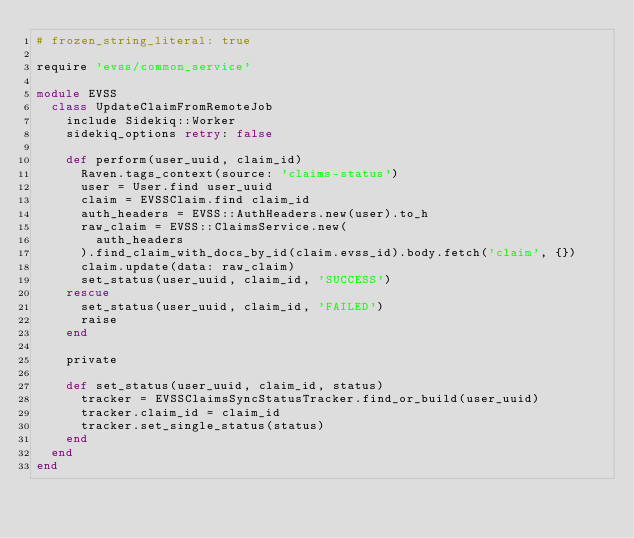Convert code to text. <code><loc_0><loc_0><loc_500><loc_500><_Ruby_># frozen_string_literal: true

require 'evss/common_service'

module EVSS
  class UpdateClaimFromRemoteJob
    include Sidekiq::Worker
    sidekiq_options retry: false

    def perform(user_uuid, claim_id)
      Raven.tags_context(source: 'claims-status')
      user = User.find user_uuid
      claim = EVSSClaim.find claim_id
      auth_headers = EVSS::AuthHeaders.new(user).to_h
      raw_claim = EVSS::ClaimsService.new(
        auth_headers
      ).find_claim_with_docs_by_id(claim.evss_id).body.fetch('claim', {})
      claim.update(data: raw_claim)
      set_status(user_uuid, claim_id, 'SUCCESS')
    rescue
      set_status(user_uuid, claim_id, 'FAILED')
      raise
    end

    private

    def set_status(user_uuid, claim_id, status)
      tracker = EVSSClaimsSyncStatusTracker.find_or_build(user_uuid)
      tracker.claim_id = claim_id
      tracker.set_single_status(status)
    end
  end
end
</code> 